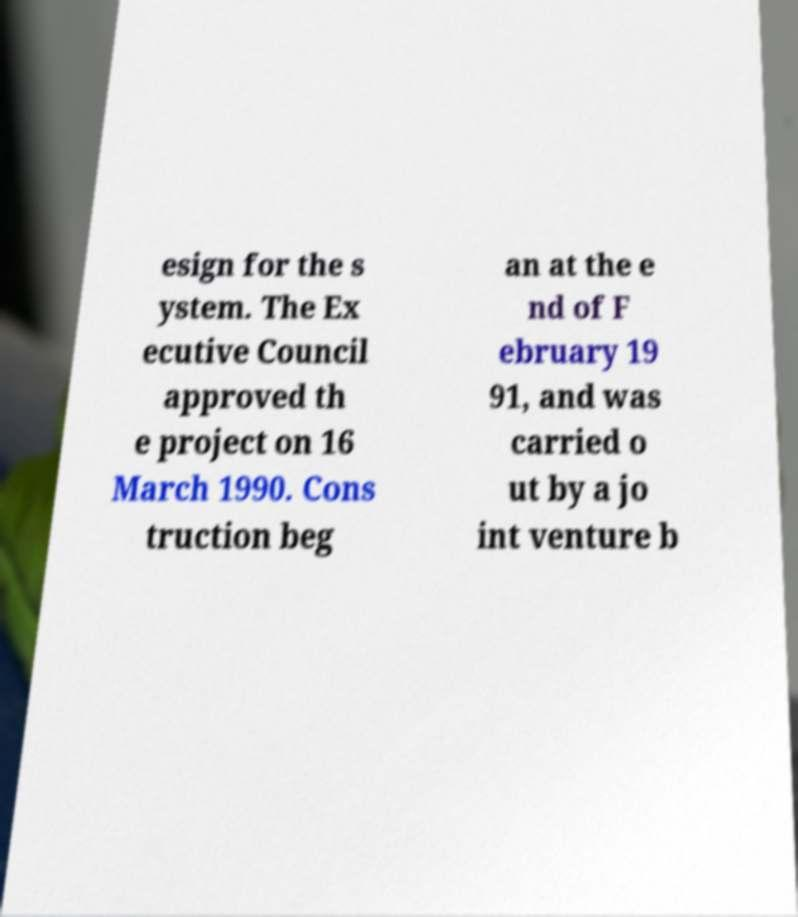There's text embedded in this image that I need extracted. Can you transcribe it verbatim? esign for the s ystem. The Ex ecutive Council approved th e project on 16 March 1990. Cons truction beg an at the e nd of F ebruary 19 91, and was carried o ut by a jo int venture b 